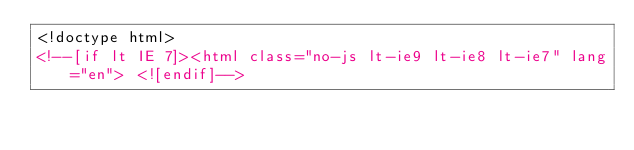<code> <loc_0><loc_0><loc_500><loc_500><_HTML_><!doctype html>
<!--[if lt IE 7]><html class="no-js lt-ie9 lt-ie8 lt-ie7" lang="en"> <![endif]--></code> 